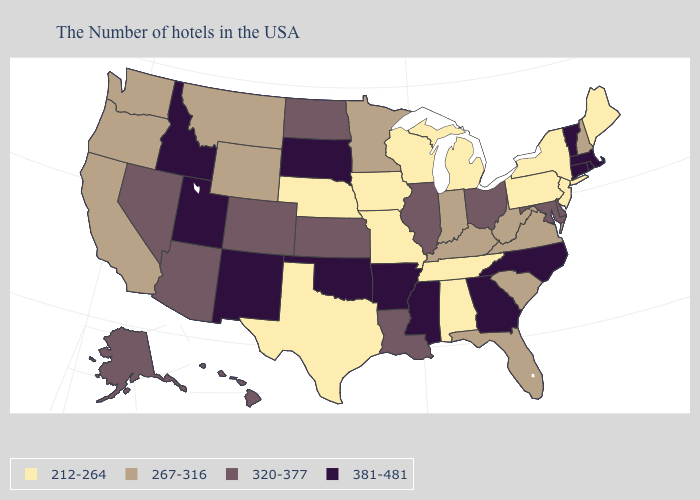What is the highest value in states that border Connecticut?
Quick response, please. 381-481. Name the states that have a value in the range 267-316?
Quick response, please. New Hampshire, Virginia, South Carolina, West Virginia, Florida, Kentucky, Indiana, Minnesota, Wyoming, Montana, California, Washington, Oregon. What is the lowest value in the MidWest?
Keep it brief. 212-264. What is the value of Missouri?
Be succinct. 212-264. Does the first symbol in the legend represent the smallest category?
Answer briefly. Yes. Does Iowa have the lowest value in the MidWest?
Short answer required. Yes. Which states have the lowest value in the South?
Short answer required. Alabama, Tennessee, Texas. Which states have the highest value in the USA?
Be succinct. Massachusetts, Rhode Island, Vermont, Connecticut, North Carolina, Georgia, Mississippi, Arkansas, Oklahoma, South Dakota, New Mexico, Utah, Idaho. What is the value of Ohio?
Keep it brief. 320-377. What is the value of Maryland?
Concise answer only. 320-377. How many symbols are there in the legend?
Write a very short answer. 4. Does the map have missing data?
Give a very brief answer. No. Among the states that border Montana , which have the highest value?
Concise answer only. South Dakota, Idaho. Name the states that have a value in the range 320-377?
Keep it brief. Delaware, Maryland, Ohio, Illinois, Louisiana, Kansas, North Dakota, Colorado, Arizona, Nevada, Alaska, Hawaii. What is the lowest value in the South?
Keep it brief. 212-264. 